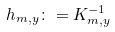Convert formula to latex. <formula><loc_0><loc_0><loc_500><loc_500>h _ { m , y } \colon = K _ { m , y } ^ { - 1 }</formula> 